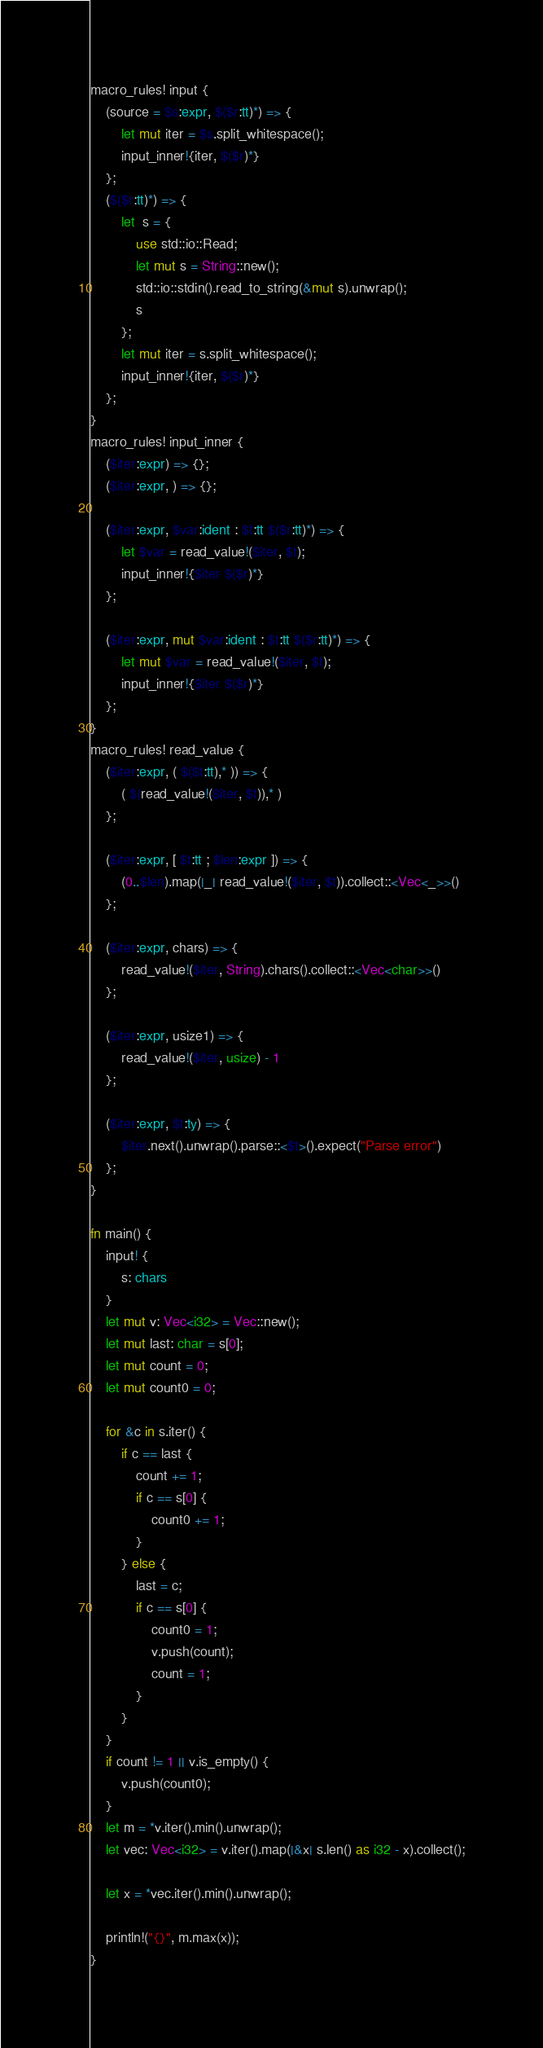Convert code to text. <code><loc_0><loc_0><loc_500><loc_500><_Rust_>macro_rules! input {
    (source = $s:expr, $($r:tt)*) => {
        let mut iter = $s.split_whitespace();
        input_inner!{iter, $($r)*}
    };
    ($($r:tt)*) => {
        let  s = {
            use std::io::Read;
            let mut s = String::new();
            std::io::stdin().read_to_string(&mut s).unwrap();
            s
        };
        let mut iter = s.split_whitespace();
        input_inner!{iter, $($r)*}
    };
}
macro_rules! input_inner {
    ($iter:expr) => {};
    ($iter:expr, ) => {};

    ($iter:expr, $var:ident : $t:tt $($r:tt)*) => {
        let $var = read_value!($iter, $t);
        input_inner!{$iter $($r)*}
    };

    ($iter:expr, mut $var:ident : $t:tt $($r:tt)*) => {
        let mut $var = read_value!($iter, $t);
        input_inner!{$iter $($r)*}
    };
}
macro_rules! read_value {
    ($iter:expr, ( $($t:tt),* )) => {
        ( $(read_value!($iter, $t)),* )
    };

    ($iter:expr, [ $t:tt ; $len:expr ]) => {
        (0..$len).map(|_| read_value!($iter, $t)).collect::<Vec<_>>()
    };

    ($iter:expr, chars) => {
        read_value!($iter, String).chars().collect::<Vec<char>>()
    };

    ($iter:expr, usize1) => {
        read_value!($iter, usize) - 1
    };

    ($iter:expr, $t:ty) => {
        $iter.next().unwrap().parse::<$t>().expect("Parse error")
    };
}

fn main() {
    input! {
        s: chars
    }
    let mut v: Vec<i32> = Vec::new();
    let mut last: char = s[0];
    let mut count = 0;
    let mut count0 = 0;

    for &c in s.iter() {
        if c == last {
            count += 1;
            if c == s[0] {
                count0 += 1;
            }
        } else {
            last = c;
            if c == s[0] {
                count0 = 1;
                v.push(count);
                count = 1;
            }
        }
    }
    if count != 1 || v.is_empty() {
        v.push(count0);
    }
    let m = *v.iter().min().unwrap();
    let vec: Vec<i32> = v.iter().map(|&x| s.len() as i32 - x).collect();

    let x = *vec.iter().min().unwrap();

    println!("{}", m.max(x));
}
</code> 